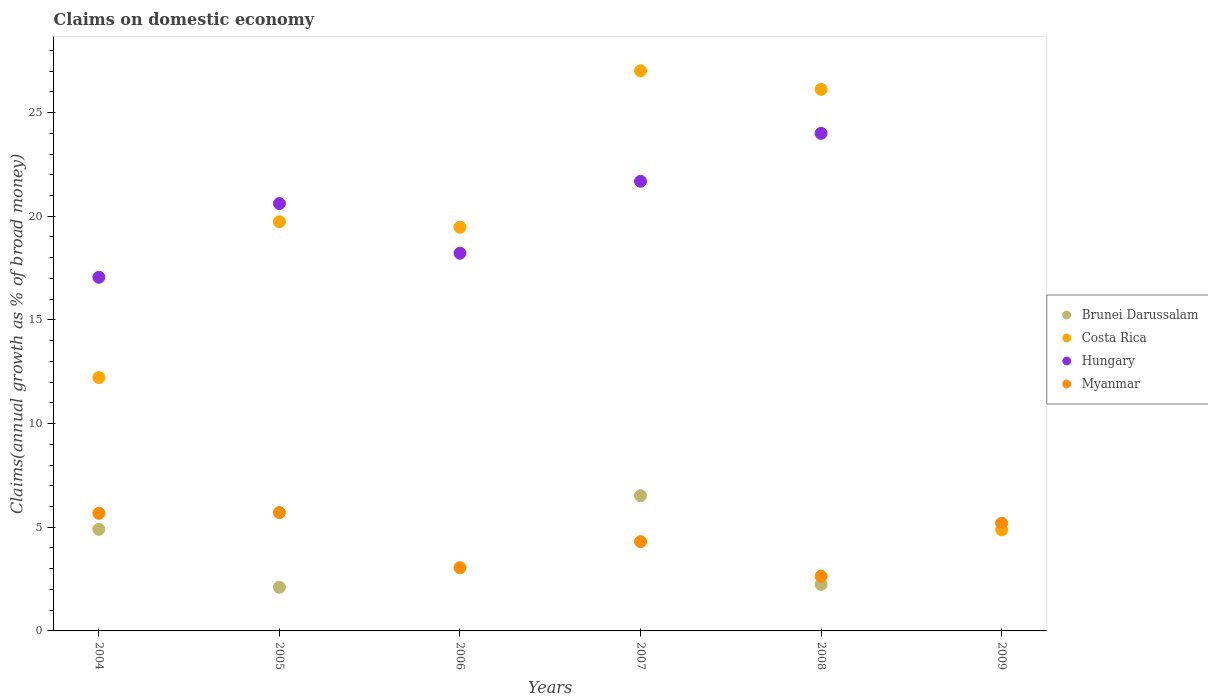How many different coloured dotlines are there?
Provide a short and direct response. 4. What is the percentage of broad money claimed on domestic economy in Myanmar in 2006?
Offer a terse response. 3.05. Across all years, what is the maximum percentage of broad money claimed on domestic economy in Brunei Darussalam?
Offer a very short reply. 6.52. Across all years, what is the minimum percentage of broad money claimed on domestic economy in Costa Rica?
Offer a very short reply. 4.88. In which year was the percentage of broad money claimed on domestic economy in Costa Rica maximum?
Your answer should be very brief. 2007. What is the total percentage of broad money claimed on domestic economy in Hungary in the graph?
Ensure brevity in your answer.  101.58. What is the difference between the percentage of broad money claimed on domestic economy in Myanmar in 2007 and that in 2009?
Your answer should be very brief. -0.89. What is the difference between the percentage of broad money claimed on domestic economy in Brunei Darussalam in 2005 and the percentage of broad money claimed on domestic economy in Costa Rica in 2007?
Offer a very short reply. -24.91. What is the average percentage of broad money claimed on domestic economy in Brunei Darussalam per year?
Your answer should be compact. 2.63. In the year 2005, what is the difference between the percentage of broad money claimed on domestic economy in Myanmar and percentage of broad money claimed on domestic economy in Hungary?
Your answer should be compact. -14.9. What is the ratio of the percentage of broad money claimed on domestic economy in Costa Rica in 2005 to that in 2007?
Make the answer very short. 0.73. Is the percentage of broad money claimed on domestic economy in Costa Rica in 2004 less than that in 2006?
Give a very brief answer. Yes. Is the difference between the percentage of broad money claimed on domestic economy in Myanmar in 2005 and 2008 greater than the difference between the percentage of broad money claimed on domestic economy in Hungary in 2005 and 2008?
Keep it short and to the point. Yes. What is the difference between the highest and the second highest percentage of broad money claimed on domestic economy in Costa Rica?
Provide a succinct answer. 0.89. What is the difference between the highest and the lowest percentage of broad money claimed on domestic economy in Costa Rica?
Your response must be concise. 22.14. In how many years, is the percentage of broad money claimed on domestic economy in Myanmar greater than the average percentage of broad money claimed on domestic economy in Myanmar taken over all years?
Your answer should be compact. 3. Is it the case that in every year, the sum of the percentage of broad money claimed on domestic economy in Brunei Darussalam and percentage of broad money claimed on domestic economy in Hungary  is greater than the sum of percentage of broad money claimed on domestic economy in Costa Rica and percentage of broad money claimed on domestic economy in Myanmar?
Your answer should be compact. No. Is it the case that in every year, the sum of the percentage of broad money claimed on domestic economy in Myanmar and percentage of broad money claimed on domestic economy in Hungary  is greater than the percentage of broad money claimed on domestic economy in Costa Rica?
Give a very brief answer. No. Does the percentage of broad money claimed on domestic economy in Myanmar monotonically increase over the years?
Your answer should be compact. No. Is the percentage of broad money claimed on domestic economy in Brunei Darussalam strictly less than the percentage of broad money claimed on domestic economy in Myanmar over the years?
Offer a terse response. No. How many years are there in the graph?
Make the answer very short. 6. How are the legend labels stacked?
Your response must be concise. Vertical. What is the title of the graph?
Ensure brevity in your answer.  Claims on domestic economy. What is the label or title of the X-axis?
Offer a very short reply. Years. What is the label or title of the Y-axis?
Provide a short and direct response. Claims(annual growth as % of broad money). What is the Claims(annual growth as % of broad money) of Brunei Darussalam in 2004?
Offer a terse response. 4.9. What is the Claims(annual growth as % of broad money) of Costa Rica in 2004?
Give a very brief answer. 12.22. What is the Claims(annual growth as % of broad money) of Hungary in 2004?
Give a very brief answer. 17.06. What is the Claims(annual growth as % of broad money) of Myanmar in 2004?
Offer a very short reply. 5.67. What is the Claims(annual growth as % of broad money) in Brunei Darussalam in 2005?
Offer a terse response. 2.11. What is the Claims(annual growth as % of broad money) in Costa Rica in 2005?
Provide a succinct answer. 19.73. What is the Claims(annual growth as % of broad money) of Hungary in 2005?
Provide a short and direct response. 20.61. What is the Claims(annual growth as % of broad money) of Myanmar in 2005?
Keep it short and to the point. 5.71. What is the Claims(annual growth as % of broad money) in Costa Rica in 2006?
Ensure brevity in your answer.  19.47. What is the Claims(annual growth as % of broad money) of Hungary in 2006?
Offer a terse response. 18.22. What is the Claims(annual growth as % of broad money) of Myanmar in 2006?
Keep it short and to the point. 3.05. What is the Claims(annual growth as % of broad money) of Brunei Darussalam in 2007?
Offer a very short reply. 6.52. What is the Claims(annual growth as % of broad money) in Costa Rica in 2007?
Your response must be concise. 27.02. What is the Claims(annual growth as % of broad money) in Hungary in 2007?
Your answer should be very brief. 21.69. What is the Claims(annual growth as % of broad money) of Myanmar in 2007?
Give a very brief answer. 4.3. What is the Claims(annual growth as % of broad money) of Brunei Darussalam in 2008?
Provide a succinct answer. 2.24. What is the Claims(annual growth as % of broad money) in Costa Rica in 2008?
Provide a short and direct response. 26.12. What is the Claims(annual growth as % of broad money) of Hungary in 2008?
Your answer should be very brief. 24. What is the Claims(annual growth as % of broad money) in Myanmar in 2008?
Ensure brevity in your answer.  2.64. What is the Claims(annual growth as % of broad money) of Brunei Darussalam in 2009?
Your response must be concise. 0. What is the Claims(annual growth as % of broad money) in Costa Rica in 2009?
Keep it short and to the point. 4.88. What is the Claims(annual growth as % of broad money) of Hungary in 2009?
Ensure brevity in your answer.  0. What is the Claims(annual growth as % of broad money) of Myanmar in 2009?
Offer a very short reply. 5.19. Across all years, what is the maximum Claims(annual growth as % of broad money) of Brunei Darussalam?
Give a very brief answer. 6.52. Across all years, what is the maximum Claims(annual growth as % of broad money) in Costa Rica?
Provide a succinct answer. 27.02. Across all years, what is the maximum Claims(annual growth as % of broad money) in Hungary?
Your answer should be compact. 24. Across all years, what is the maximum Claims(annual growth as % of broad money) of Myanmar?
Ensure brevity in your answer.  5.71. Across all years, what is the minimum Claims(annual growth as % of broad money) in Costa Rica?
Provide a short and direct response. 4.88. Across all years, what is the minimum Claims(annual growth as % of broad money) in Myanmar?
Ensure brevity in your answer.  2.64. What is the total Claims(annual growth as % of broad money) in Brunei Darussalam in the graph?
Offer a terse response. 15.77. What is the total Claims(annual growth as % of broad money) in Costa Rica in the graph?
Your answer should be compact. 109.44. What is the total Claims(annual growth as % of broad money) in Hungary in the graph?
Give a very brief answer. 101.58. What is the total Claims(annual growth as % of broad money) in Myanmar in the graph?
Offer a very short reply. 26.56. What is the difference between the Claims(annual growth as % of broad money) in Brunei Darussalam in 2004 and that in 2005?
Give a very brief answer. 2.79. What is the difference between the Claims(annual growth as % of broad money) in Costa Rica in 2004 and that in 2005?
Keep it short and to the point. -7.51. What is the difference between the Claims(annual growth as % of broad money) of Hungary in 2004 and that in 2005?
Ensure brevity in your answer.  -3.56. What is the difference between the Claims(annual growth as % of broad money) in Myanmar in 2004 and that in 2005?
Your response must be concise. -0.04. What is the difference between the Claims(annual growth as % of broad money) of Costa Rica in 2004 and that in 2006?
Offer a very short reply. -7.25. What is the difference between the Claims(annual growth as % of broad money) in Hungary in 2004 and that in 2006?
Ensure brevity in your answer.  -1.16. What is the difference between the Claims(annual growth as % of broad money) in Myanmar in 2004 and that in 2006?
Offer a very short reply. 2.62. What is the difference between the Claims(annual growth as % of broad money) of Brunei Darussalam in 2004 and that in 2007?
Your response must be concise. -1.62. What is the difference between the Claims(annual growth as % of broad money) in Costa Rica in 2004 and that in 2007?
Offer a terse response. -14.8. What is the difference between the Claims(annual growth as % of broad money) of Hungary in 2004 and that in 2007?
Give a very brief answer. -4.63. What is the difference between the Claims(annual growth as % of broad money) of Myanmar in 2004 and that in 2007?
Ensure brevity in your answer.  1.37. What is the difference between the Claims(annual growth as % of broad money) of Brunei Darussalam in 2004 and that in 2008?
Offer a terse response. 2.66. What is the difference between the Claims(annual growth as % of broad money) in Costa Rica in 2004 and that in 2008?
Offer a terse response. -13.9. What is the difference between the Claims(annual growth as % of broad money) of Hungary in 2004 and that in 2008?
Keep it short and to the point. -6.94. What is the difference between the Claims(annual growth as % of broad money) in Myanmar in 2004 and that in 2008?
Give a very brief answer. 3.03. What is the difference between the Claims(annual growth as % of broad money) of Costa Rica in 2004 and that in 2009?
Your answer should be compact. 7.34. What is the difference between the Claims(annual growth as % of broad money) of Myanmar in 2004 and that in 2009?
Offer a terse response. 0.48. What is the difference between the Claims(annual growth as % of broad money) of Costa Rica in 2005 and that in 2006?
Offer a terse response. 0.26. What is the difference between the Claims(annual growth as % of broad money) of Hungary in 2005 and that in 2006?
Your response must be concise. 2.4. What is the difference between the Claims(annual growth as % of broad money) of Myanmar in 2005 and that in 2006?
Provide a short and direct response. 2.66. What is the difference between the Claims(annual growth as % of broad money) of Brunei Darussalam in 2005 and that in 2007?
Your response must be concise. -4.42. What is the difference between the Claims(annual growth as % of broad money) in Costa Rica in 2005 and that in 2007?
Offer a terse response. -7.28. What is the difference between the Claims(annual growth as % of broad money) of Hungary in 2005 and that in 2007?
Offer a terse response. -1.07. What is the difference between the Claims(annual growth as % of broad money) in Myanmar in 2005 and that in 2007?
Ensure brevity in your answer.  1.41. What is the difference between the Claims(annual growth as % of broad money) of Brunei Darussalam in 2005 and that in 2008?
Your answer should be compact. -0.14. What is the difference between the Claims(annual growth as % of broad money) in Costa Rica in 2005 and that in 2008?
Keep it short and to the point. -6.39. What is the difference between the Claims(annual growth as % of broad money) of Hungary in 2005 and that in 2008?
Keep it short and to the point. -3.38. What is the difference between the Claims(annual growth as % of broad money) of Myanmar in 2005 and that in 2008?
Offer a very short reply. 3.07. What is the difference between the Claims(annual growth as % of broad money) in Costa Rica in 2005 and that in 2009?
Offer a very short reply. 14.86. What is the difference between the Claims(annual growth as % of broad money) in Myanmar in 2005 and that in 2009?
Your answer should be compact. 0.52. What is the difference between the Claims(annual growth as % of broad money) of Costa Rica in 2006 and that in 2007?
Your response must be concise. -7.55. What is the difference between the Claims(annual growth as % of broad money) in Hungary in 2006 and that in 2007?
Provide a short and direct response. -3.47. What is the difference between the Claims(annual growth as % of broad money) in Myanmar in 2006 and that in 2007?
Your response must be concise. -1.25. What is the difference between the Claims(annual growth as % of broad money) in Costa Rica in 2006 and that in 2008?
Your response must be concise. -6.65. What is the difference between the Claims(annual growth as % of broad money) in Hungary in 2006 and that in 2008?
Make the answer very short. -5.78. What is the difference between the Claims(annual growth as % of broad money) of Myanmar in 2006 and that in 2008?
Your answer should be very brief. 0.41. What is the difference between the Claims(annual growth as % of broad money) in Costa Rica in 2006 and that in 2009?
Your answer should be very brief. 14.59. What is the difference between the Claims(annual growth as % of broad money) in Myanmar in 2006 and that in 2009?
Your response must be concise. -2.14. What is the difference between the Claims(annual growth as % of broad money) of Brunei Darussalam in 2007 and that in 2008?
Offer a very short reply. 4.28. What is the difference between the Claims(annual growth as % of broad money) in Costa Rica in 2007 and that in 2008?
Provide a succinct answer. 0.89. What is the difference between the Claims(annual growth as % of broad money) in Hungary in 2007 and that in 2008?
Provide a short and direct response. -2.31. What is the difference between the Claims(annual growth as % of broad money) of Myanmar in 2007 and that in 2008?
Provide a short and direct response. 1.66. What is the difference between the Claims(annual growth as % of broad money) in Costa Rica in 2007 and that in 2009?
Give a very brief answer. 22.14. What is the difference between the Claims(annual growth as % of broad money) in Myanmar in 2007 and that in 2009?
Ensure brevity in your answer.  -0.89. What is the difference between the Claims(annual growth as % of broad money) of Costa Rica in 2008 and that in 2009?
Your response must be concise. 21.25. What is the difference between the Claims(annual growth as % of broad money) in Myanmar in 2008 and that in 2009?
Keep it short and to the point. -2.55. What is the difference between the Claims(annual growth as % of broad money) of Brunei Darussalam in 2004 and the Claims(annual growth as % of broad money) of Costa Rica in 2005?
Your answer should be very brief. -14.83. What is the difference between the Claims(annual growth as % of broad money) in Brunei Darussalam in 2004 and the Claims(annual growth as % of broad money) in Hungary in 2005?
Give a very brief answer. -15.71. What is the difference between the Claims(annual growth as % of broad money) of Brunei Darussalam in 2004 and the Claims(annual growth as % of broad money) of Myanmar in 2005?
Your response must be concise. -0.81. What is the difference between the Claims(annual growth as % of broad money) of Costa Rica in 2004 and the Claims(annual growth as % of broad money) of Hungary in 2005?
Give a very brief answer. -8.39. What is the difference between the Claims(annual growth as % of broad money) of Costa Rica in 2004 and the Claims(annual growth as % of broad money) of Myanmar in 2005?
Make the answer very short. 6.51. What is the difference between the Claims(annual growth as % of broad money) of Hungary in 2004 and the Claims(annual growth as % of broad money) of Myanmar in 2005?
Your response must be concise. 11.35. What is the difference between the Claims(annual growth as % of broad money) of Brunei Darussalam in 2004 and the Claims(annual growth as % of broad money) of Costa Rica in 2006?
Ensure brevity in your answer.  -14.57. What is the difference between the Claims(annual growth as % of broad money) of Brunei Darussalam in 2004 and the Claims(annual growth as % of broad money) of Hungary in 2006?
Provide a succinct answer. -13.32. What is the difference between the Claims(annual growth as % of broad money) in Brunei Darussalam in 2004 and the Claims(annual growth as % of broad money) in Myanmar in 2006?
Provide a succinct answer. 1.85. What is the difference between the Claims(annual growth as % of broad money) in Costa Rica in 2004 and the Claims(annual growth as % of broad money) in Hungary in 2006?
Offer a very short reply. -6. What is the difference between the Claims(annual growth as % of broad money) of Costa Rica in 2004 and the Claims(annual growth as % of broad money) of Myanmar in 2006?
Give a very brief answer. 9.17. What is the difference between the Claims(annual growth as % of broad money) in Hungary in 2004 and the Claims(annual growth as % of broad money) in Myanmar in 2006?
Provide a succinct answer. 14.01. What is the difference between the Claims(annual growth as % of broad money) of Brunei Darussalam in 2004 and the Claims(annual growth as % of broad money) of Costa Rica in 2007?
Offer a terse response. -22.12. What is the difference between the Claims(annual growth as % of broad money) in Brunei Darussalam in 2004 and the Claims(annual growth as % of broad money) in Hungary in 2007?
Offer a very short reply. -16.79. What is the difference between the Claims(annual growth as % of broad money) of Brunei Darussalam in 2004 and the Claims(annual growth as % of broad money) of Myanmar in 2007?
Make the answer very short. 0.6. What is the difference between the Claims(annual growth as % of broad money) of Costa Rica in 2004 and the Claims(annual growth as % of broad money) of Hungary in 2007?
Your answer should be compact. -9.47. What is the difference between the Claims(annual growth as % of broad money) in Costa Rica in 2004 and the Claims(annual growth as % of broad money) in Myanmar in 2007?
Keep it short and to the point. 7.92. What is the difference between the Claims(annual growth as % of broad money) of Hungary in 2004 and the Claims(annual growth as % of broad money) of Myanmar in 2007?
Your answer should be compact. 12.75. What is the difference between the Claims(annual growth as % of broad money) in Brunei Darussalam in 2004 and the Claims(annual growth as % of broad money) in Costa Rica in 2008?
Provide a succinct answer. -21.22. What is the difference between the Claims(annual growth as % of broad money) in Brunei Darussalam in 2004 and the Claims(annual growth as % of broad money) in Hungary in 2008?
Make the answer very short. -19.1. What is the difference between the Claims(annual growth as % of broad money) in Brunei Darussalam in 2004 and the Claims(annual growth as % of broad money) in Myanmar in 2008?
Your response must be concise. 2.26. What is the difference between the Claims(annual growth as % of broad money) of Costa Rica in 2004 and the Claims(annual growth as % of broad money) of Hungary in 2008?
Your answer should be very brief. -11.78. What is the difference between the Claims(annual growth as % of broad money) of Costa Rica in 2004 and the Claims(annual growth as % of broad money) of Myanmar in 2008?
Make the answer very short. 9.58. What is the difference between the Claims(annual growth as % of broad money) of Hungary in 2004 and the Claims(annual growth as % of broad money) of Myanmar in 2008?
Keep it short and to the point. 14.42. What is the difference between the Claims(annual growth as % of broad money) of Brunei Darussalam in 2004 and the Claims(annual growth as % of broad money) of Costa Rica in 2009?
Offer a very short reply. 0.02. What is the difference between the Claims(annual growth as % of broad money) in Brunei Darussalam in 2004 and the Claims(annual growth as % of broad money) in Myanmar in 2009?
Provide a succinct answer. -0.29. What is the difference between the Claims(annual growth as % of broad money) in Costa Rica in 2004 and the Claims(annual growth as % of broad money) in Myanmar in 2009?
Offer a terse response. 7.03. What is the difference between the Claims(annual growth as % of broad money) in Hungary in 2004 and the Claims(annual growth as % of broad money) in Myanmar in 2009?
Give a very brief answer. 11.87. What is the difference between the Claims(annual growth as % of broad money) in Brunei Darussalam in 2005 and the Claims(annual growth as % of broad money) in Costa Rica in 2006?
Keep it short and to the point. -17.36. What is the difference between the Claims(annual growth as % of broad money) in Brunei Darussalam in 2005 and the Claims(annual growth as % of broad money) in Hungary in 2006?
Your answer should be compact. -16.11. What is the difference between the Claims(annual growth as % of broad money) in Brunei Darussalam in 2005 and the Claims(annual growth as % of broad money) in Myanmar in 2006?
Your answer should be very brief. -0.94. What is the difference between the Claims(annual growth as % of broad money) in Costa Rica in 2005 and the Claims(annual growth as % of broad money) in Hungary in 2006?
Provide a succinct answer. 1.52. What is the difference between the Claims(annual growth as % of broad money) of Costa Rica in 2005 and the Claims(annual growth as % of broad money) of Myanmar in 2006?
Provide a succinct answer. 16.68. What is the difference between the Claims(annual growth as % of broad money) in Hungary in 2005 and the Claims(annual growth as % of broad money) in Myanmar in 2006?
Offer a terse response. 17.56. What is the difference between the Claims(annual growth as % of broad money) in Brunei Darussalam in 2005 and the Claims(annual growth as % of broad money) in Costa Rica in 2007?
Ensure brevity in your answer.  -24.91. What is the difference between the Claims(annual growth as % of broad money) in Brunei Darussalam in 2005 and the Claims(annual growth as % of broad money) in Hungary in 2007?
Offer a very short reply. -19.58. What is the difference between the Claims(annual growth as % of broad money) in Brunei Darussalam in 2005 and the Claims(annual growth as % of broad money) in Myanmar in 2007?
Keep it short and to the point. -2.2. What is the difference between the Claims(annual growth as % of broad money) of Costa Rica in 2005 and the Claims(annual growth as % of broad money) of Hungary in 2007?
Keep it short and to the point. -1.95. What is the difference between the Claims(annual growth as % of broad money) of Costa Rica in 2005 and the Claims(annual growth as % of broad money) of Myanmar in 2007?
Offer a very short reply. 15.43. What is the difference between the Claims(annual growth as % of broad money) in Hungary in 2005 and the Claims(annual growth as % of broad money) in Myanmar in 2007?
Your response must be concise. 16.31. What is the difference between the Claims(annual growth as % of broad money) in Brunei Darussalam in 2005 and the Claims(annual growth as % of broad money) in Costa Rica in 2008?
Give a very brief answer. -24.01. What is the difference between the Claims(annual growth as % of broad money) in Brunei Darussalam in 2005 and the Claims(annual growth as % of broad money) in Hungary in 2008?
Give a very brief answer. -21.89. What is the difference between the Claims(annual growth as % of broad money) of Brunei Darussalam in 2005 and the Claims(annual growth as % of broad money) of Myanmar in 2008?
Provide a short and direct response. -0.53. What is the difference between the Claims(annual growth as % of broad money) in Costa Rica in 2005 and the Claims(annual growth as % of broad money) in Hungary in 2008?
Offer a very short reply. -4.27. What is the difference between the Claims(annual growth as % of broad money) in Costa Rica in 2005 and the Claims(annual growth as % of broad money) in Myanmar in 2008?
Ensure brevity in your answer.  17.09. What is the difference between the Claims(annual growth as % of broad money) of Hungary in 2005 and the Claims(annual growth as % of broad money) of Myanmar in 2008?
Your response must be concise. 17.97. What is the difference between the Claims(annual growth as % of broad money) of Brunei Darussalam in 2005 and the Claims(annual growth as % of broad money) of Costa Rica in 2009?
Offer a very short reply. -2.77. What is the difference between the Claims(annual growth as % of broad money) of Brunei Darussalam in 2005 and the Claims(annual growth as % of broad money) of Myanmar in 2009?
Your response must be concise. -3.08. What is the difference between the Claims(annual growth as % of broad money) of Costa Rica in 2005 and the Claims(annual growth as % of broad money) of Myanmar in 2009?
Give a very brief answer. 14.54. What is the difference between the Claims(annual growth as % of broad money) in Hungary in 2005 and the Claims(annual growth as % of broad money) in Myanmar in 2009?
Offer a terse response. 15.42. What is the difference between the Claims(annual growth as % of broad money) in Costa Rica in 2006 and the Claims(annual growth as % of broad money) in Hungary in 2007?
Offer a very short reply. -2.22. What is the difference between the Claims(annual growth as % of broad money) of Costa Rica in 2006 and the Claims(annual growth as % of broad money) of Myanmar in 2007?
Offer a terse response. 15.17. What is the difference between the Claims(annual growth as % of broad money) in Hungary in 2006 and the Claims(annual growth as % of broad money) in Myanmar in 2007?
Your answer should be compact. 13.91. What is the difference between the Claims(annual growth as % of broad money) in Costa Rica in 2006 and the Claims(annual growth as % of broad money) in Hungary in 2008?
Make the answer very short. -4.53. What is the difference between the Claims(annual growth as % of broad money) in Costa Rica in 2006 and the Claims(annual growth as % of broad money) in Myanmar in 2008?
Your answer should be very brief. 16.83. What is the difference between the Claims(annual growth as % of broad money) of Hungary in 2006 and the Claims(annual growth as % of broad money) of Myanmar in 2008?
Keep it short and to the point. 15.58. What is the difference between the Claims(annual growth as % of broad money) of Costa Rica in 2006 and the Claims(annual growth as % of broad money) of Myanmar in 2009?
Keep it short and to the point. 14.28. What is the difference between the Claims(annual growth as % of broad money) of Hungary in 2006 and the Claims(annual growth as % of broad money) of Myanmar in 2009?
Your answer should be very brief. 13.03. What is the difference between the Claims(annual growth as % of broad money) of Brunei Darussalam in 2007 and the Claims(annual growth as % of broad money) of Costa Rica in 2008?
Provide a succinct answer. -19.6. What is the difference between the Claims(annual growth as % of broad money) of Brunei Darussalam in 2007 and the Claims(annual growth as % of broad money) of Hungary in 2008?
Your answer should be very brief. -17.48. What is the difference between the Claims(annual growth as % of broad money) in Brunei Darussalam in 2007 and the Claims(annual growth as % of broad money) in Myanmar in 2008?
Your answer should be very brief. 3.88. What is the difference between the Claims(annual growth as % of broad money) in Costa Rica in 2007 and the Claims(annual growth as % of broad money) in Hungary in 2008?
Provide a succinct answer. 3.02. What is the difference between the Claims(annual growth as % of broad money) in Costa Rica in 2007 and the Claims(annual growth as % of broad money) in Myanmar in 2008?
Provide a short and direct response. 24.38. What is the difference between the Claims(annual growth as % of broad money) in Hungary in 2007 and the Claims(annual growth as % of broad money) in Myanmar in 2008?
Keep it short and to the point. 19.05. What is the difference between the Claims(annual growth as % of broad money) in Brunei Darussalam in 2007 and the Claims(annual growth as % of broad money) in Costa Rica in 2009?
Your answer should be compact. 1.65. What is the difference between the Claims(annual growth as % of broad money) in Brunei Darussalam in 2007 and the Claims(annual growth as % of broad money) in Myanmar in 2009?
Provide a succinct answer. 1.33. What is the difference between the Claims(annual growth as % of broad money) of Costa Rica in 2007 and the Claims(annual growth as % of broad money) of Myanmar in 2009?
Give a very brief answer. 21.83. What is the difference between the Claims(annual growth as % of broad money) of Hungary in 2007 and the Claims(annual growth as % of broad money) of Myanmar in 2009?
Your response must be concise. 16.5. What is the difference between the Claims(annual growth as % of broad money) in Brunei Darussalam in 2008 and the Claims(annual growth as % of broad money) in Costa Rica in 2009?
Ensure brevity in your answer.  -2.63. What is the difference between the Claims(annual growth as % of broad money) of Brunei Darussalam in 2008 and the Claims(annual growth as % of broad money) of Myanmar in 2009?
Provide a succinct answer. -2.95. What is the difference between the Claims(annual growth as % of broad money) of Costa Rica in 2008 and the Claims(annual growth as % of broad money) of Myanmar in 2009?
Your answer should be very brief. 20.93. What is the difference between the Claims(annual growth as % of broad money) in Hungary in 2008 and the Claims(annual growth as % of broad money) in Myanmar in 2009?
Your answer should be compact. 18.81. What is the average Claims(annual growth as % of broad money) of Brunei Darussalam per year?
Keep it short and to the point. 2.63. What is the average Claims(annual growth as % of broad money) of Costa Rica per year?
Provide a succinct answer. 18.24. What is the average Claims(annual growth as % of broad money) in Hungary per year?
Your response must be concise. 16.93. What is the average Claims(annual growth as % of broad money) in Myanmar per year?
Give a very brief answer. 4.43. In the year 2004, what is the difference between the Claims(annual growth as % of broad money) in Brunei Darussalam and Claims(annual growth as % of broad money) in Costa Rica?
Make the answer very short. -7.32. In the year 2004, what is the difference between the Claims(annual growth as % of broad money) in Brunei Darussalam and Claims(annual growth as % of broad money) in Hungary?
Your response must be concise. -12.16. In the year 2004, what is the difference between the Claims(annual growth as % of broad money) in Brunei Darussalam and Claims(annual growth as % of broad money) in Myanmar?
Offer a very short reply. -0.77. In the year 2004, what is the difference between the Claims(annual growth as % of broad money) of Costa Rica and Claims(annual growth as % of broad money) of Hungary?
Provide a short and direct response. -4.84. In the year 2004, what is the difference between the Claims(annual growth as % of broad money) in Costa Rica and Claims(annual growth as % of broad money) in Myanmar?
Provide a short and direct response. 6.55. In the year 2004, what is the difference between the Claims(annual growth as % of broad money) of Hungary and Claims(annual growth as % of broad money) of Myanmar?
Your answer should be very brief. 11.38. In the year 2005, what is the difference between the Claims(annual growth as % of broad money) in Brunei Darussalam and Claims(annual growth as % of broad money) in Costa Rica?
Offer a very short reply. -17.63. In the year 2005, what is the difference between the Claims(annual growth as % of broad money) of Brunei Darussalam and Claims(annual growth as % of broad money) of Hungary?
Keep it short and to the point. -18.51. In the year 2005, what is the difference between the Claims(annual growth as % of broad money) of Brunei Darussalam and Claims(annual growth as % of broad money) of Myanmar?
Offer a very short reply. -3.6. In the year 2005, what is the difference between the Claims(annual growth as % of broad money) in Costa Rica and Claims(annual growth as % of broad money) in Hungary?
Provide a short and direct response. -0.88. In the year 2005, what is the difference between the Claims(annual growth as % of broad money) of Costa Rica and Claims(annual growth as % of broad money) of Myanmar?
Your answer should be compact. 14.02. In the year 2005, what is the difference between the Claims(annual growth as % of broad money) in Hungary and Claims(annual growth as % of broad money) in Myanmar?
Offer a very short reply. 14.9. In the year 2006, what is the difference between the Claims(annual growth as % of broad money) in Costa Rica and Claims(annual growth as % of broad money) in Hungary?
Your answer should be compact. 1.25. In the year 2006, what is the difference between the Claims(annual growth as % of broad money) of Costa Rica and Claims(annual growth as % of broad money) of Myanmar?
Keep it short and to the point. 16.42. In the year 2006, what is the difference between the Claims(annual growth as % of broad money) in Hungary and Claims(annual growth as % of broad money) in Myanmar?
Your answer should be very brief. 15.17. In the year 2007, what is the difference between the Claims(annual growth as % of broad money) of Brunei Darussalam and Claims(annual growth as % of broad money) of Costa Rica?
Ensure brevity in your answer.  -20.49. In the year 2007, what is the difference between the Claims(annual growth as % of broad money) of Brunei Darussalam and Claims(annual growth as % of broad money) of Hungary?
Offer a terse response. -15.17. In the year 2007, what is the difference between the Claims(annual growth as % of broad money) of Brunei Darussalam and Claims(annual growth as % of broad money) of Myanmar?
Your answer should be very brief. 2.22. In the year 2007, what is the difference between the Claims(annual growth as % of broad money) of Costa Rica and Claims(annual growth as % of broad money) of Hungary?
Give a very brief answer. 5.33. In the year 2007, what is the difference between the Claims(annual growth as % of broad money) of Costa Rica and Claims(annual growth as % of broad money) of Myanmar?
Your answer should be compact. 22.71. In the year 2007, what is the difference between the Claims(annual growth as % of broad money) in Hungary and Claims(annual growth as % of broad money) in Myanmar?
Make the answer very short. 17.38. In the year 2008, what is the difference between the Claims(annual growth as % of broad money) in Brunei Darussalam and Claims(annual growth as % of broad money) in Costa Rica?
Your answer should be very brief. -23.88. In the year 2008, what is the difference between the Claims(annual growth as % of broad money) in Brunei Darussalam and Claims(annual growth as % of broad money) in Hungary?
Your response must be concise. -21.76. In the year 2008, what is the difference between the Claims(annual growth as % of broad money) in Brunei Darussalam and Claims(annual growth as % of broad money) in Myanmar?
Make the answer very short. -0.4. In the year 2008, what is the difference between the Claims(annual growth as % of broad money) in Costa Rica and Claims(annual growth as % of broad money) in Hungary?
Provide a succinct answer. 2.12. In the year 2008, what is the difference between the Claims(annual growth as % of broad money) in Costa Rica and Claims(annual growth as % of broad money) in Myanmar?
Your response must be concise. 23.48. In the year 2008, what is the difference between the Claims(annual growth as % of broad money) in Hungary and Claims(annual growth as % of broad money) in Myanmar?
Give a very brief answer. 21.36. In the year 2009, what is the difference between the Claims(annual growth as % of broad money) in Costa Rica and Claims(annual growth as % of broad money) in Myanmar?
Your response must be concise. -0.31. What is the ratio of the Claims(annual growth as % of broad money) of Brunei Darussalam in 2004 to that in 2005?
Ensure brevity in your answer.  2.33. What is the ratio of the Claims(annual growth as % of broad money) of Costa Rica in 2004 to that in 2005?
Ensure brevity in your answer.  0.62. What is the ratio of the Claims(annual growth as % of broad money) in Hungary in 2004 to that in 2005?
Offer a terse response. 0.83. What is the ratio of the Claims(annual growth as % of broad money) in Myanmar in 2004 to that in 2005?
Provide a short and direct response. 0.99. What is the ratio of the Claims(annual growth as % of broad money) in Costa Rica in 2004 to that in 2006?
Offer a very short reply. 0.63. What is the ratio of the Claims(annual growth as % of broad money) in Hungary in 2004 to that in 2006?
Offer a terse response. 0.94. What is the ratio of the Claims(annual growth as % of broad money) in Myanmar in 2004 to that in 2006?
Ensure brevity in your answer.  1.86. What is the ratio of the Claims(annual growth as % of broad money) in Brunei Darussalam in 2004 to that in 2007?
Offer a terse response. 0.75. What is the ratio of the Claims(annual growth as % of broad money) in Costa Rica in 2004 to that in 2007?
Offer a terse response. 0.45. What is the ratio of the Claims(annual growth as % of broad money) in Hungary in 2004 to that in 2007?
Ensure brevity in your answer.  0.79. What is the ratio of the Claims(annual growth as % of broad money) in Myanmar in 2004 to that in 2007?
Provide a succinct answer. 1.32. What is the ratio of the Claims(annual growth as % of broad money) in Brunei Darussalam in 2004 to that in 2008?
Your answer should be compact. 2.18. What is the ratio of the Claims(annual growth as % of broad money) in Costa Rica in 2004 to that in 2008?
Offer a very short reply. 0.47. What is the ratio of the Claims(annual growth as % of broad money) in Hungary in 2004 to that in 2008?
Provide a succinct answer. 0.71. What is the ratio of the Claims(annual growth as % of broad money) in Myanmar in 2004 to that in 2008?
Provide a succinct answer. 2.15. What is the ratio of the Claims(annual growth as % of broad money) in Costa Rica in 2004 to that in 2009?
Your answer should be compact. 2.51. What is the ratio of the Claims(annual growth as % of broad money) of Myanmar in 2004 to that in 2009?
Ensure brevity in your answer.  1.09. What is the ratio of the Claims(annual growth as % of broad money) in Costa Rica in 2005 to that in 2006?
Your answer should be compact. 1.01. What is the ratio of the Claims(annual growth as % of broad money) of Hungary in 2005 to that in 2006?
Keep it short and to the point. 1.13. What is the ratio of the Claims(annual growth as % of broad money) in Myanmar in 2005 to that in 2006?
Offer a terse response. 1.87. What is the ratio of the Claims(annual growth as % of broad money) in Brunei Darussalam in 2005 to that in 2007?
Your answer should be compact. 0.32. What is the ratio of the Claims(annual growth as % of broad money) in Costa Rica in 2005 to that in 2007?
Ensure brevity in your answer.  0.73. What is the ratio of the Claims(annual growth as % of broad money) of Hungary in 2005 to that in 2007?
Give a very brief answer. 0.95. What is the ratio of the Claims(annual growth as % of broad money) of Myanmar in 2005 to that in 2007?
Ensure brevity in your answer.  1.33. What is the ratio of the Claims(annual growth as % of broad money) of Brunei Darussalam in 2005 to that in 2008?
Your response must be concise. 0.94. What is the ratio of the Claims(annual growth as % of broad money) of Costa Rica in 2005 to that in 2008?
Provide a succinct answer. 0.76. What is the ratio of the Claims(annual growth as % of broad money) in Hungary in 2005 to that in 2008?
Keep it short and to the point. 0.86. What is the ratio of the Claims(annual growth as % of broad money) in Myanmar in 2005 to that in 2008?
Provide a short and direct response. 2.16. What is the ratio of the Claims(annual growth as % of broad money) of Costa Rica in 2005 to that in 2009?
Provide a succinct answer. 4.05. What is the ratio of the Claims(annual growth as % of broad money) of Myanmar in 2005 to that in 2009?
Your answer should be compact. 1.1. What is the ratio of the Claims(annual growth as % of broad money) in Costa Rica in 2006 to that in 2007?
Give a very brief answer. 0.72. What is the ratio of the Claims(annual growth as % of broad money) of Hungary in 2006 to that in 2007?
Ensure brevity in your answer.  0.84. What is the ratio of the Claims(annual growth as % of broad money) in Myanmar in 2006 to that in 2007?
Ensure brevity in your answer.  0.71. What is the ratio of the Claims(annual growth as % of broad money) in Costa Rica in 2006 to that in 2008?
Give a very brief answer. 0.75. What is the ratio of the Claims(annual growth as % of broad money) of Hungary in 2006 to that in 2008?
Provide a short and direct response. 0.76. What is the ratio of the Claims(annual growth as % of broad money) of Myanmar in 2006 to that in 2008?
Ensure brevity in your answer.  1.16. What is the ratio of the Claims(annual growth as % of broad money) in Costa Rica in 2006 to that in 2009?
Offer a very short reply. 3.99. What is the ratio of the Claims(annual growth as % of broad money) of Myanmar in 2006 to that in 2009?
Provide a short and direct response. 0.59. What is the ratio of the Claims(annual growth as % of broad money) in Brunei Darussalam in 2007 to that in 2008?
Give a very brief answer. 2.91. What is the ratio of the Claims(annual growth as % of broad money) in Costa Rica in 2007 to that in 2008?
Provide a succinct answer. 1.03. What is the ratio of the Claims(annual growth as % of broad money) in Hungary in 2007 to that in 2008?
Make the answer very short. 0.9. What is the ratio of the Claims(annual growth as % of broad money) in Myanmar in 2007 to that in 2008?
Your response must be concise. 1.63. What is the ratio of the Claims(annual growth as % of broad money) of Costa Rica in 2007 to that in 2009?
Your answer should be compact. 5.54. What is the ratio of the Claims(annual growth as % of broad money) in Myanmar in 2007 to that in 2009?
Your answer should be compact. 0.83. What is the ratio of the Claims(annual growth as % of broad money) of Costa Rica in 2008 to that in 2009?
Your answer should be very brief. 5.36. What is the ratio of the Claims(annual growth as % of broad money) of Myanmar in 2008 to that in 2009?
Your response must be concise. 0.51. What is the difference between the highest and the second highest Claims(annual growth as % of broad money) of Brunei Darussalam?
Your answer should be compact. 1.62. What is the difference between the highest and the second highest Claims(annual growth as % of broad money) of Costa Rica?
Your response must be concise. 0.89. What is the difference between the highest and the second highest Claims(annual growth as % of broad money) of Hungary?
Your response must be concise. 2.31. What is the difference between the highest and the second highest Claims(annual growth as % of broad money) of Myanmar?
Give a very brief answer. 0.04. What is the difference between the highest and the lowest Claims(annual growth as % of broad money) of Brunei Darussalam?
Ensure brevity in your answer.  6.52. What is the difference between the highest and the lowest Claims(annual growth as % of broad money) of Costa Rica?
Ensure brevity in your answer.  22.14. What is the difference between the highest and the lowest Claims(annual growth as % of broad money) in Hungary?
Offer a very short reply. 24. What is the difference between the highest and the lowest Claims(annual growth as % of broad money) in Myanmar?
Offer a very short reply. 3.07. 